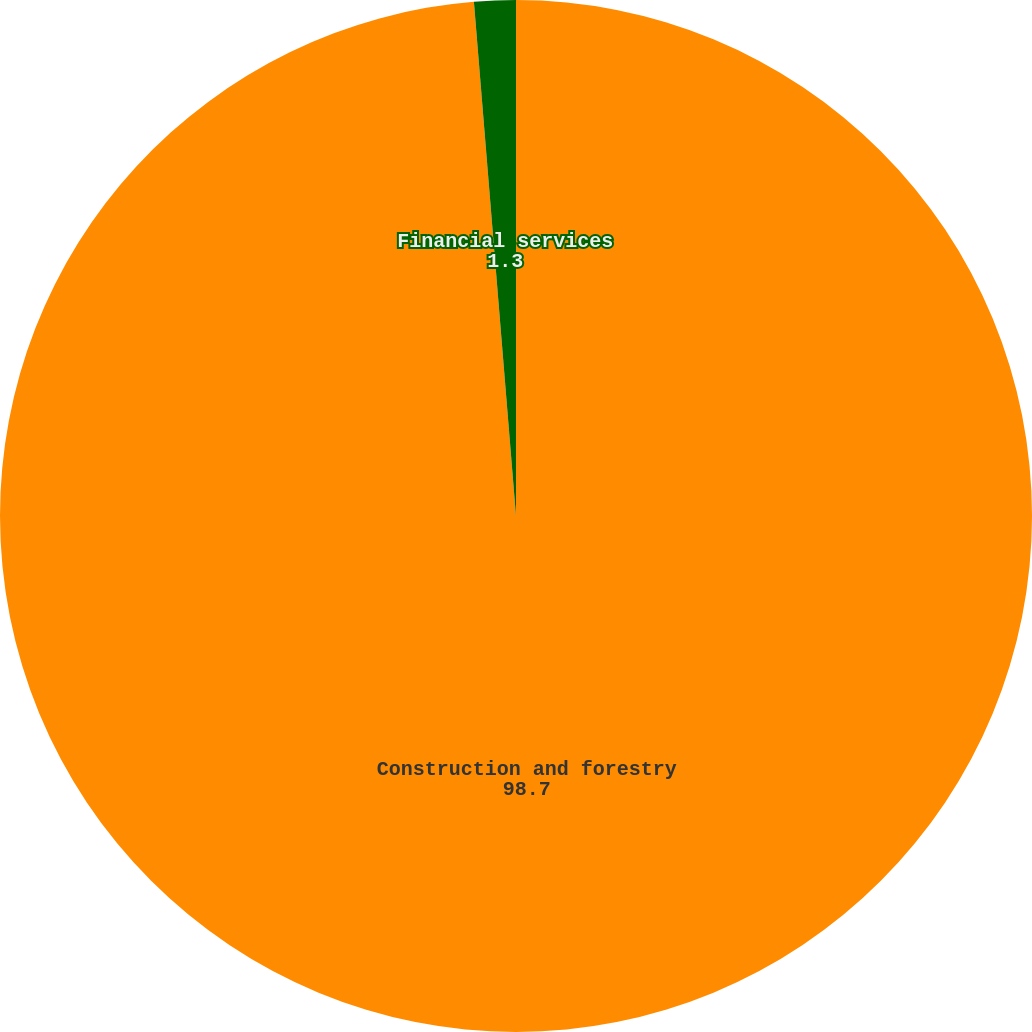Convert chart. <chart><loc_0><loc_0><loc_500><loc_500><pie_chart><fcel>Construction and forestry<fcel>Financial services<nl><fcel>98.7%<fcel>1.3%<nl></chart> 